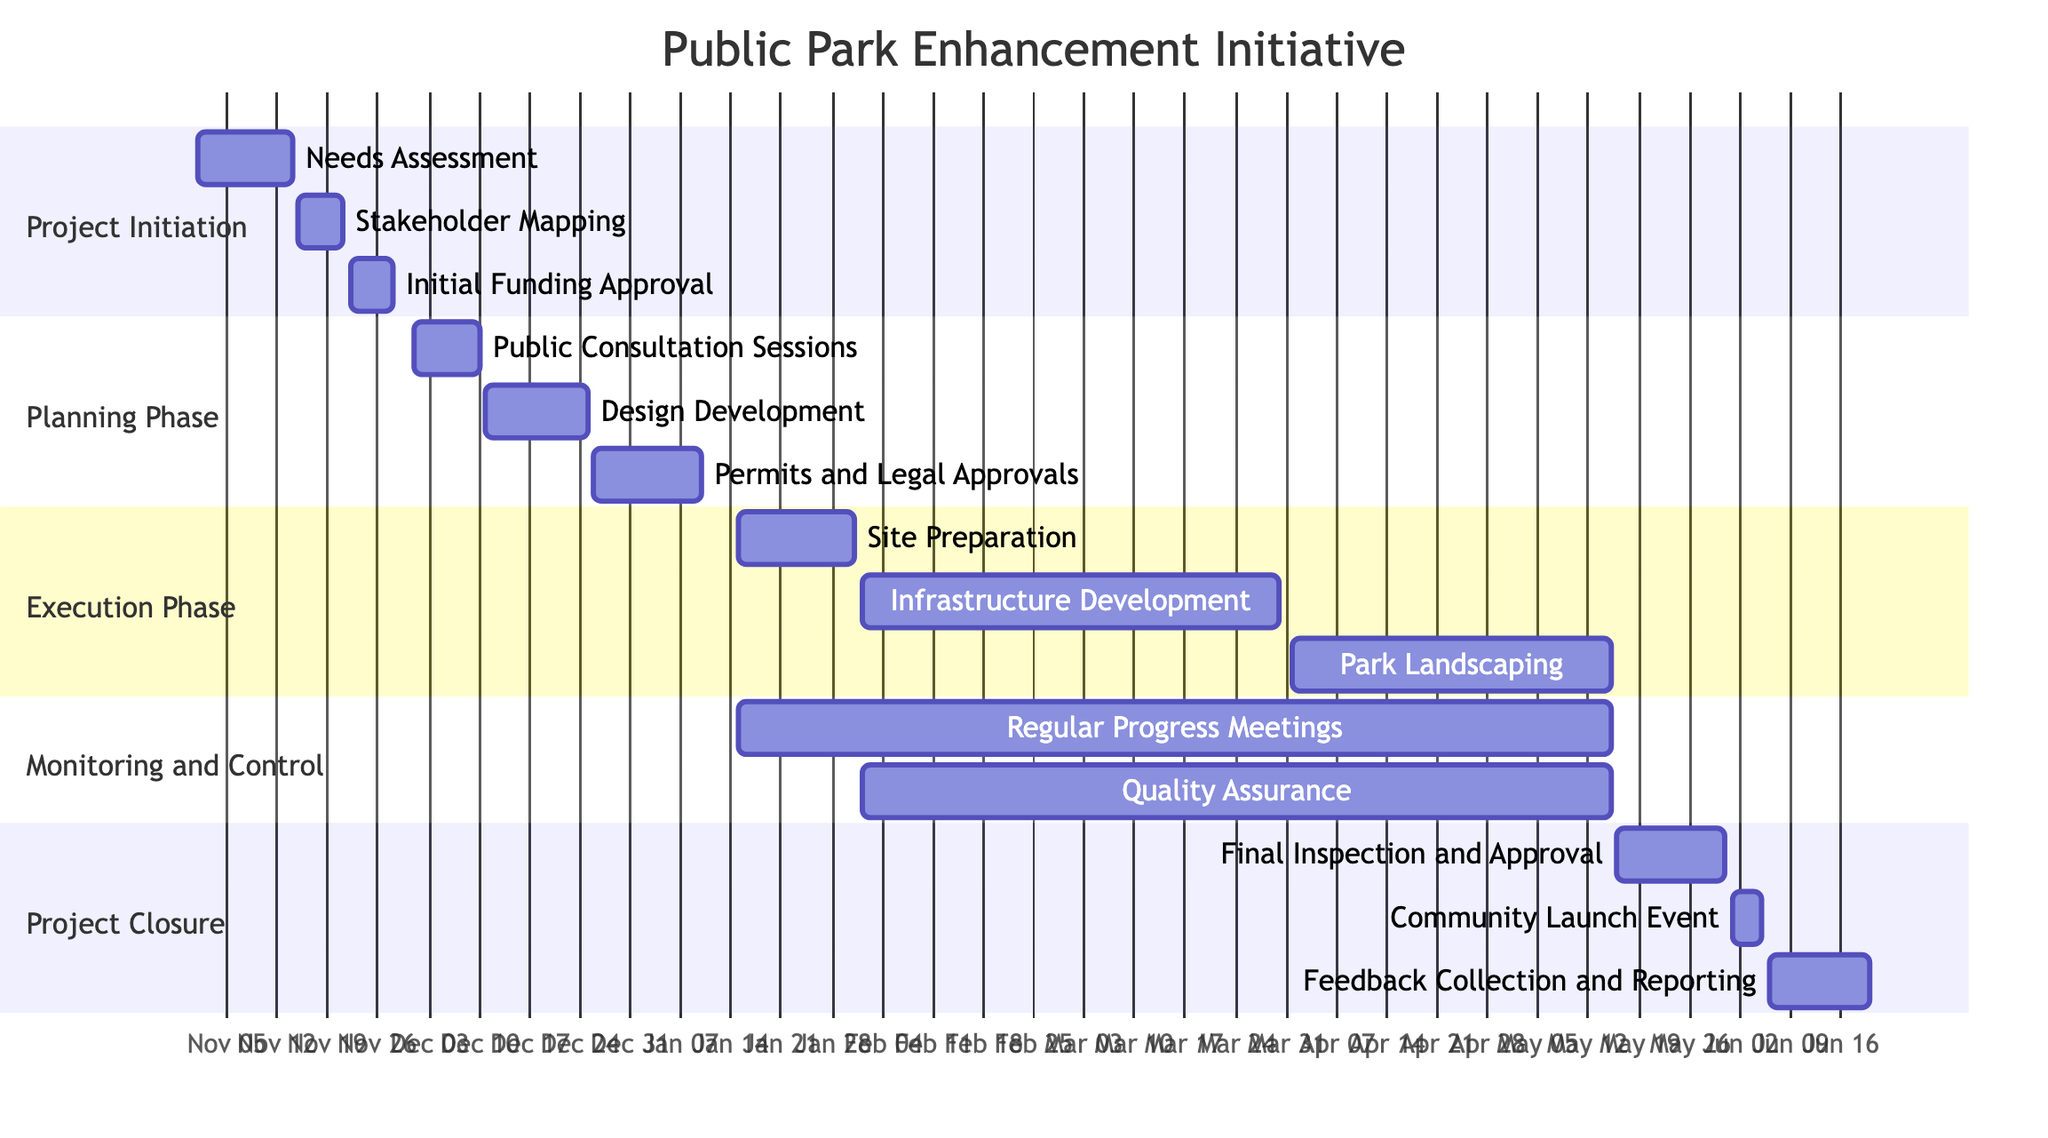What is the duration of the "Needs Assessment" task? The "Needs Assessment" task starts on November 1, 2023, and ends on November 14, 2023. The duration is calculated by counting the number of days from the start date to the end date, inclusive. This results in a total of 14 days.
Answer: 14 days Which task follows "Public Consultation Sessions" in the planning phase? The tasks in the planning phase are listed in chronological order. The task "Public Consultation Sessions" starts on December 1, 2023, and ends on December 10, 2023. The next task, "Design Development," starts on December 11, 2023, which is right after "Public Consultation Sessions."
Answer: Design Development How many tasks are there in the "Execution Phase"? The "Execution Phase" contains three tasks listed under it: "Site Preparation," "Infrastructure Development," and "Park Landscaping." By counting these tasks, we can determine the total number of tasks in this phase.
Answer: 3 Which stakeholders are involved in the "Quality Assurance" task? The "Quality Assurance" task includes stakeholders involved as shown in the diagram. Specifically, the stakeholders listed for this task are "Quality Inspectors," "City Planners," and "Local Community Groups."
Answer: Quality Inspectors, City Planners, Local Community Groups What is the start date of the "Final Inspection and Approval"? The "Final Inspection and Approval" task in the project closure phase begins on May 16, 2024. This information is directly visible in the diagram for this specific task.
Answer: May 16, 2024 During which phase do the "Regular Progress Meetings" occur? The "Regular Progress Meetings" task overlaps multiple phases, but it specifically starts in the "Monitoring and Control" phase on January 15, 2024. This task is indicated in the diagram under the relevant section.
Answer: Monitoring and Control What is the last task of the project and when does it end? The last task listed in the project is "Feedback Collection and Reporting," which ends on June 20, 2024. By reviewing the project closure phase, we can identify this as the final task.
Answer: June 20, 2024 What is the total duration of the planning phase? The planning phase starts on December 1, 2023, with "Public Consultation Sessions" and ends on January 10, 2024, with "Permits and Legal Approvals." To find the total duration, we count the days from the start of the first task to the end of the last task. This results in a duration of 41 days.
Answer: 41 days Which stakeholder is involved in the "Initial Funding Approval" task? The "Initial Funding Approval" task lists three stakeholders: "City Treasurer," "City Council," and "Local Business Sponsors." Each of these stakeholders plays a role in this task as shown in the diagram.
Answer: City Treasurer, City Council, Local Business Sponsors 